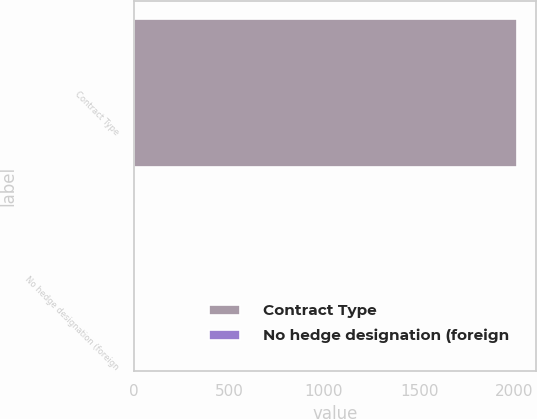<chart> <loc_0><loc_0><loc_500><loc_500><bar_chart><fcel>Contract Type<fcel>No hedge designation (foreign<nl><fcel>2014<fcel>5<nl></chart> 